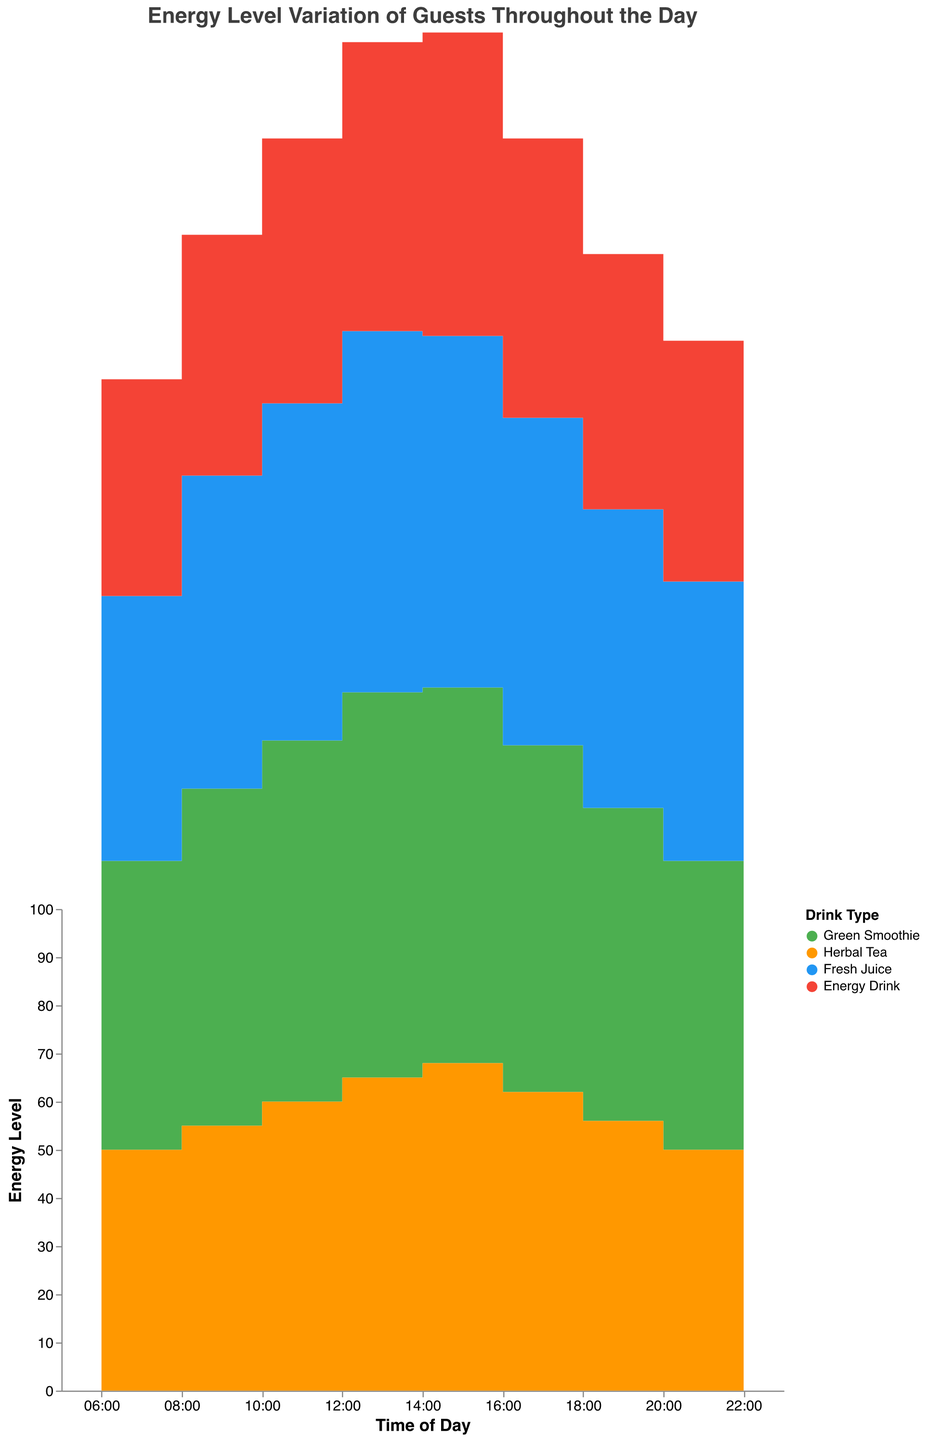What is the title of the chart? The title of the chart is located at the top of the figure and typically gives a summary of what the chart represents. The title here states what the chart is about.
Answer: Energy Level Variation of Guests Throughout the Day At what time do herbal tea drinkers experience the highest energy level? By examining the herbal tea line on the chart, observe the y-axis for the highest data point for herbal tea and note the corresponding time on the x-axis.
Answer: 14:00 Which drink shows the steepest increase in energy level between 06:00 and 12:00? Look at all the lines from 06:00 to 12:00 and identify which drink shows the greatest change in height (y-axis) over this period. Green Smoothie starts at 60 and increases to 80, making it a 20 point increase which is the largest among all lines.
Answer: Green Smoothie What is the difference in energy levels between Fresh Juice drinkers and Energy Drink drinkers at 10:00? Locate the energy levels for both Fresh Juice and Energy Drink at 10:00 on the chart. Fresh Juice is at 70 and Energy Drink is at 55. Subtract the latter from the former to find the difference.
Answer: 15 At what time of day do all the drinks show the lowest energy levels? Identify the time on the x-axis where all lines are relatively at their lowest points.
Answer: 22:00 Which drink maintains a relatively stable energy level throughout the day? Observe all the lines and note which one has the least fluctuations and remains fairly stable. Herbal Tea’s line shows the least fluctuation, staying between 48 and 68.
Answer: Herbal Tea Calculate the average energy level of Green Smoothie drinkers from 06:00 to 18:00. Add the Green Smoothie values from 06:00 to 18:00 and divide by the number of data points to get the average: (60 + 70 + 75 + 80 + 78 + 72 + 65) / 7.
Answer: 71.43 Compare the energy levels between Green Smoothie and Fresh Juice drinkers at 14:00. Which one is higher? Find the energy levels for both Green Smoothie and Fresh Juice at 14:00 on the chart. Green Smoothie is 78, Fresh Juice is 73. Green Smoothie is higher.
Answer: Green Smoothie How does the energy level for Energy Drink drinkers change from 12:00 to 18:00? Track the Energy Drink line from 12:00 to 18:00, noting the decrease from 60 at 12:00 to 53 at 18:00. The energy levels decrease by 7 points.
Answer: It decreases What is the total change in energy level for Herbal Tea drinkers from 06:00 to 22:00? Subtract the energy level at 06:00 from the energy level at 22:00 for Herbal Tea: 50 at 06:00 and 48 at 22:00, so the total change is 50 - 48.
Answer: -2 